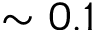Convert formula to latex. <formula><loc_0><loc_0><loc_500><loc_500>\sim 0 . 1</formula> 